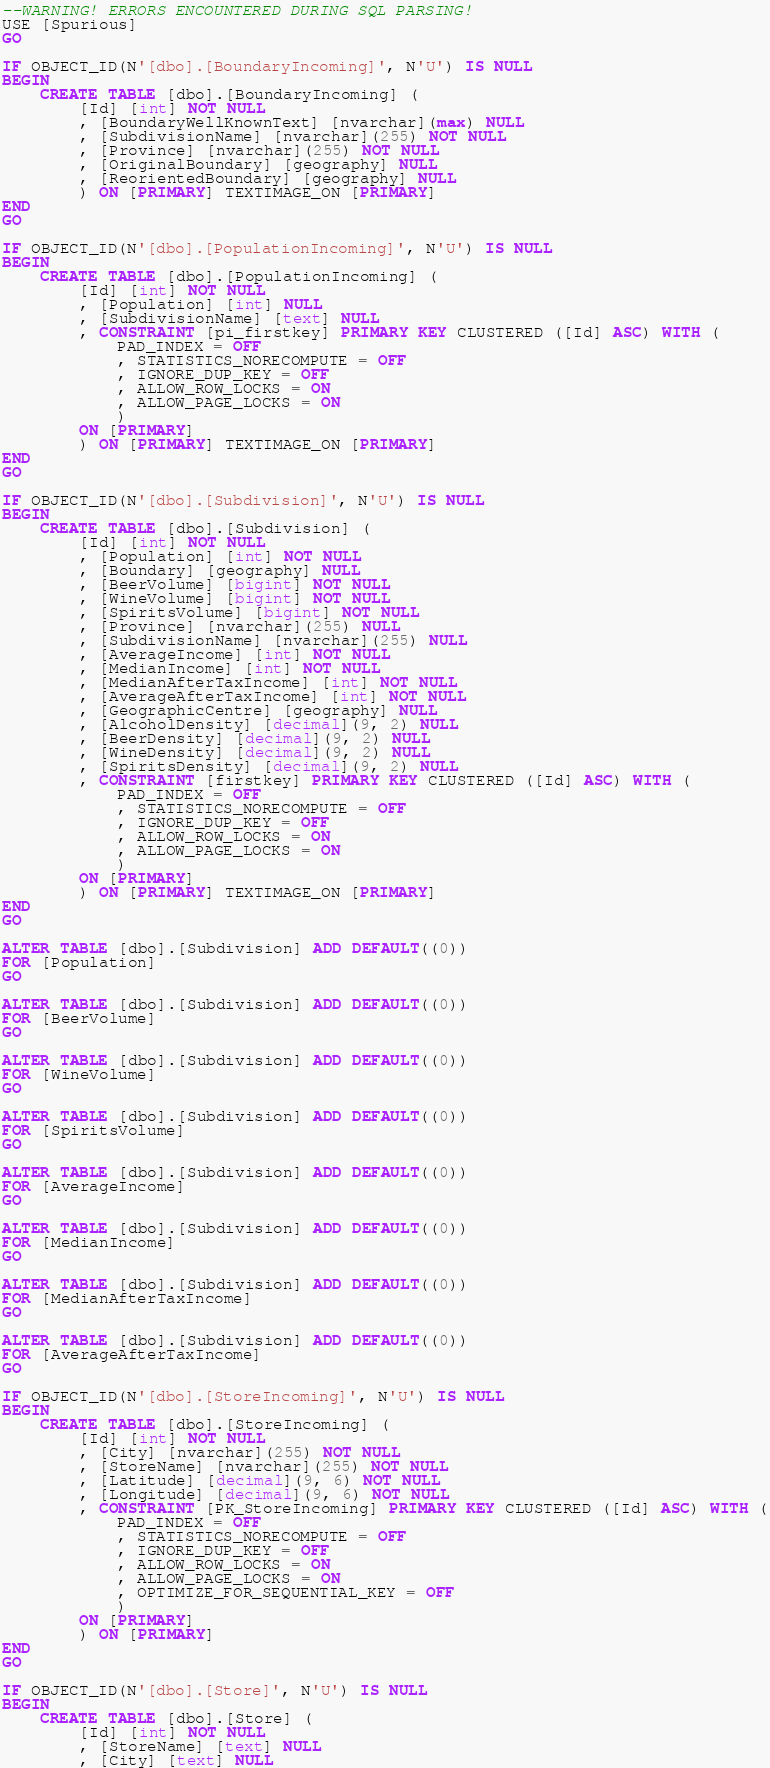Convert code to text. <code><loc_0><loc_0><loc_500><loc_500><_SQL_>--WARNING! ERRORS ENCOUNTERED DURING SQL PARSING!
USE [Spurious]
GO

IF OBJECT_ID(N'[dbo].[BoundaryIncoming]', N'U') IS NULL
BEGIN
    CREATE TABLE [dbo].[BoundaryIncoming] (
        [Id] [int] NOT NULL
        , [BoundaryWellKnownText] [nvarchar](max) NULL
        , [SubdivisionName] [nvarchar](255) NOT NULL
        , [Province] [nvarchar](255) NOT NULL
        , [OriginalBoundary] [geography] NULL
        , [ReorientedBoundary] [geography] NULL
        ) ON [PRIMARY] TEXTIMAGE_ON [PRIMARY]
END
GO

IF OBJECT_ID(N'[dbo].[PopulationIncoming]', N'U') IS NULL
BEGIN
    CREATE TABLE [dbo].[PopulationIncoming] (
        [Id] [int] NOT NULL
        , [Population] [int] NULL
        , [SubdivisionName] [text] NULL
        , CONSTRAINT [pi_firstkey] PRIMARY KEY CLUSTERED ([Id] ASC) WITH (
            PAD_INDEX = OFF
            , STATISTICS_NORECOMPUTE = OFF
            , IGNORE_DUP_KEY = OFF
            , ALLOW_ROW_LOCKS = ON
            , ALLOW_PAGE_LOCKS = ON
            )
        ON [PRIMARY]
        ) ON [PRIMARY] TEXTIMAGE_ON [PRIMARY]
END
GO

IF OBJECT_ID(N'[dbo].[Subdivision]', N'U') IS NULL
BEGIN
    CREATE TABLE [dbo].[Subdivision] (
        [Id] [int] NOT NULL
        , [Population] [int] NOT NULL
        , [Boundary] [geography] NULL
        , [BeerVolume] [bigint] NOT NULL
        , [WineVolume] [bigint] NOT NULL
        , [SpiritsVolume] [bigint] NOT NULL
        , [Province] [nvarchar](255) NULL
        , [SubdivisionName] [nvarchar](255) NULL
        , [AverageIncome] [int] NOT NULL
        , [MedianIncome] [int] NOT NULL
        , [MedianAfterTaxIncome] [int] NOT NULL
        , [AverageAfterTaxIncome] [int] NOT NULL
        , [GeographicCentre] [geography] NULL
        , [AlcoholDensity] [decimal](9, 2) NULL
        , [BeerDensity] [decimal](9, 2) NULL
        , [WineDensity] [decimal](9, 2) NULL
        , [SpiritsDensity] [decimal](9, 2) NULL
        , CONSTRAINT [firstkey] PRIMARY KEY CLUSTERED ([Id] ASC) WITH (
            PAD_INDEX = OFF
            , STATISTICS_NORECOMPUTE = OFF
            , IGNORE_DUP_KEY = OFF
            , ALLOW_ROW_LOCKS = ON
            , ALLOW_PAGE_LOCKS = ON
            )
        ON [PRIMARY]
        ) ON [PRIMARY] TEXTIMAGE_ON [PRIMARY]
END
GO

ALTER TABLE [dbo].[Subdivision] ADD DEFAULT((0))
FOR [Population]
GO

ALTER TABLE [dbo].[Subdivision] ADD DEFAULT((0))
FOR [BeerVolume]
GO

ALTER TABLE [dbo].[Subdivision] ADD DEFAULT((0))
FOR [WineVolume]
GO

ALTER TABLE [dbo].[Subdivision] ADD DEFAULT((0))
FOR [SpiritsVolume]
GO

ALTER TABLE [dbo].[Subdivision] ADD DEFAULT((0))
FOR [AverageIncome]
GO

ALTER TABLE [dbo].[Subdivision] ADD DEFAULT((0))
FOR [MedianIncome]
GO

ALTER TABLE [dbo].[Subdivision] ADD DEFAULT((0))
FOR [MedianAfterTaxIncome]
GO

ALTER TABLE [dbo].[Subdivision] ADD DEFAULT((0))
FOR [AverageAfterTaxIncome]
GO

IF OBJECT_ID(N'[dbo].[StoreIncoming]', N'U') IS NULL
BEGIN
    CREATE TABLE [dbo].[StoreIncoming] (
        [Id] [int] NOT NULL
        , [City] [nvarchar](255) NOT NULL
        , [StoreName] [nvarchar](255) NOT NULL
        , [Latitude] [decimal](9, 6) NOT NULL
        , [Longitude] [decimal](9, 6) NOT NULL
        , CONSTRAINT [PK_StoreIncoming] PRIMARY KEY CLUSTERED ([Id] ASC) WITH (
            PAD_INDEX = OFF
            , STATISTICS_NORECOMPUTE = OFF
            , IGNORE_DUP_KEY = OFF
            , ALLOW_ROW_LOCKS = ON
            , ALLOW_PAGE_LOCKS = ON
            , OPTIMIZE_FOR_SEQUENTIAL_KEY = OFF
            )
        ON [PRIMARY]
        ) ON [PRIMARY]
END
GO

IF OBJECT_ID(N'[dbo].[Store]', N'U') IS NULL
BEGIN
    CREATE TABLE [dbo].[Store] (
        [Id] [int] NOT NULL
        , [StoreName] [text] NULL
        , [City] [text] NULL</code> 